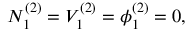<formula> <loc_0><loc_0><loc_500><loc_500>N _ { 1 } ^ { ( 2 ) } = V _ { 1 } ^ { ( 2 ) } = \phi _ { 1 } ^ { ( 2 ) } = 0 ,</formula> 